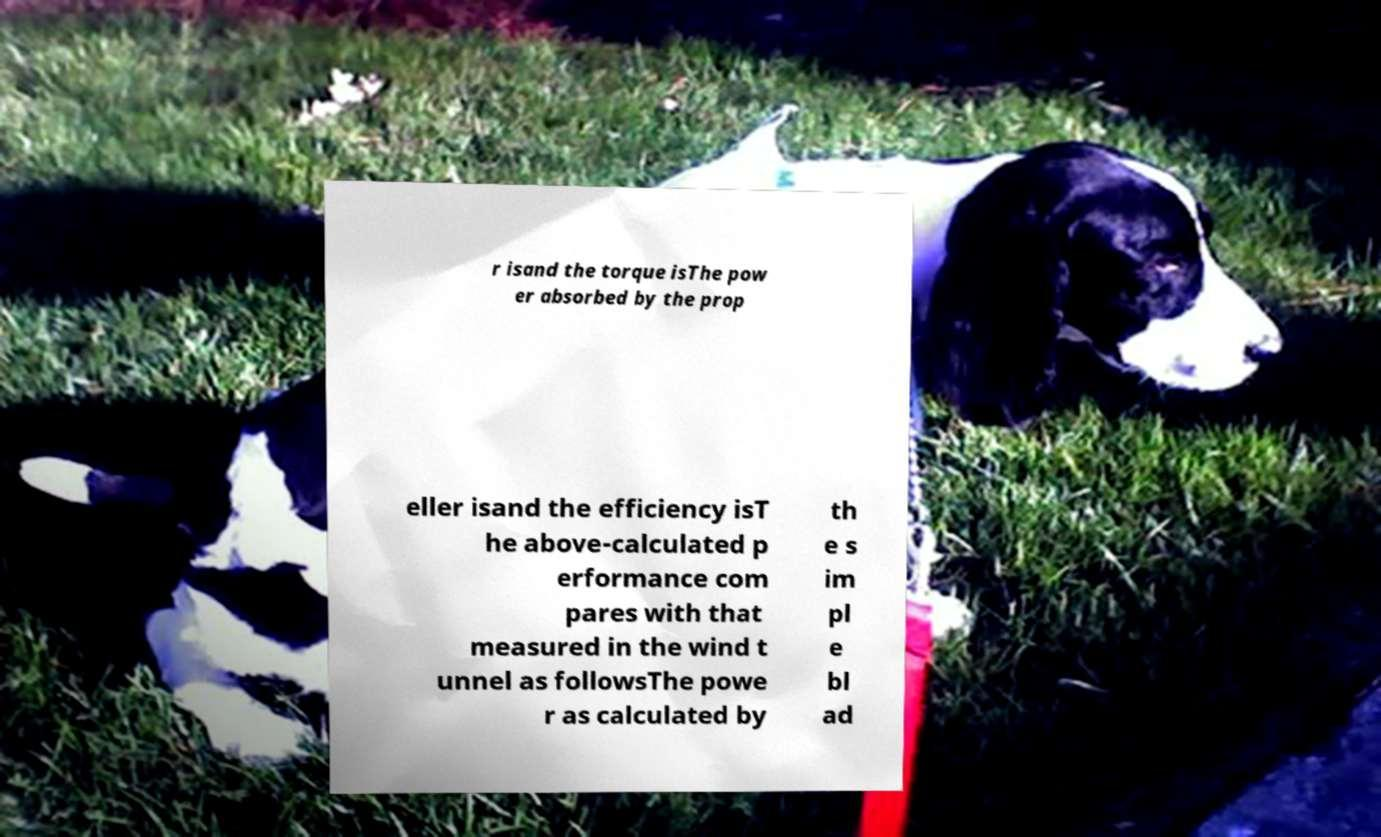I need the written content from this picture converted into text. Can you do that? r isand the torque isThe pow er absorbed by the prop eller isand the efficiency isT he above-calculated p erformance com pares with that measured in the wind t unnel as followsThe powe r as calculated by th e s im pl e bl ad 